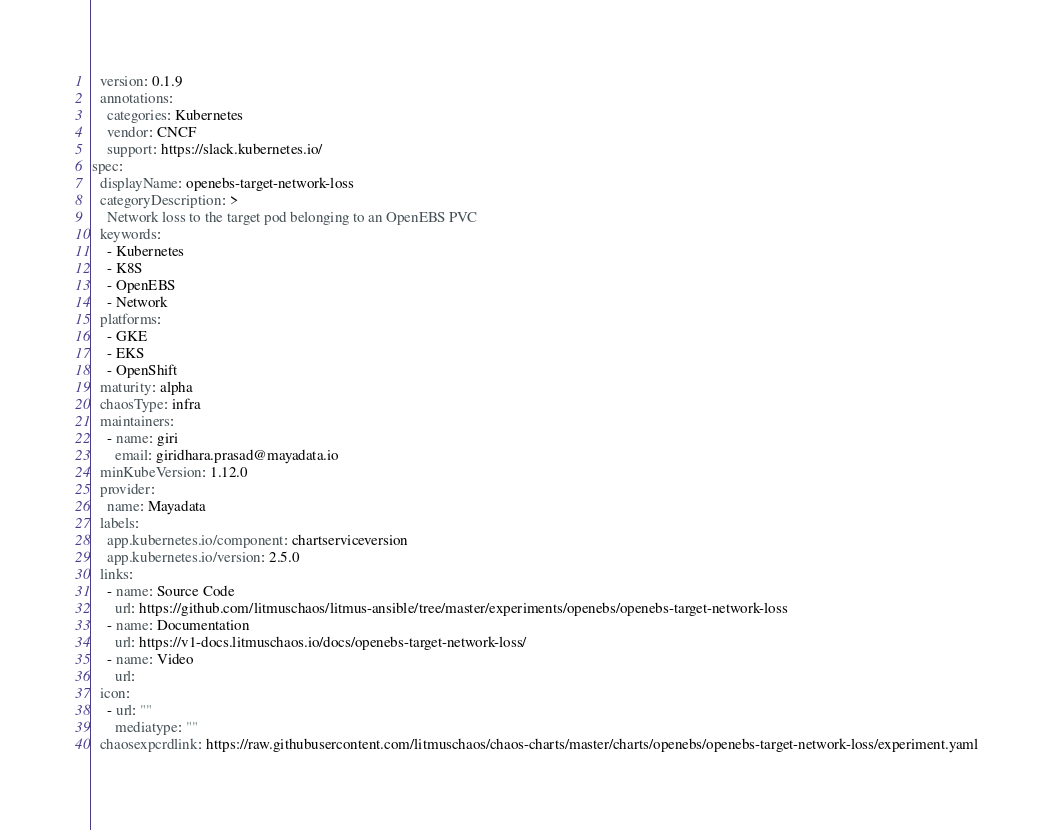Convert code to text. <code><loc_0><loc_0><loc_500><loc_500><_YAML_>  version: 0.1.9
  annotations:
    categories: Kubernetes
    vendor: CNCF
    support: https://slack.kubernetes.io/
spec:
  displayName: openebs-target-network-loss
  categoryDescription: >
    Network loss to the target pod belonging to an OpenEBS PVC
  keywords:
    - Kubernetes
    - K8S
    - OpenEBS 
    - Network
  platforms:
    - GKE
    - EKS
    - OpenShift
  maturity: alpha
  chaosType: infra
  maintainers:
    - name: giri
      email: giridhara.prasad@mayadata.io
  minKubeVersion: 1.12.0
  provider:
    name: Mayadata
  labels:
    app.kubernetes.io/component: chartserviceversion
    app.kubernetes.io/version: 2.5.0
  links:
    - name: Source Code
      url: https://github.com/litmuschaos/litmus-ansible/tree/master/experiments/openebs/openebs-target-network-loss
    - name: Documentation
      url: https://v1-docs.litmuschaos.io/docs/openebs-target-network-loss/
    - name: Video
      url:
  icon:
    - url: ""
      mediatype: ""
  chaosexpcrdlink: https://raw.githubusercontent.com/litmuschaos/chaos-charts/master/charts/openebs/openebs-target-network-loss/experiment.yaml
</code> 